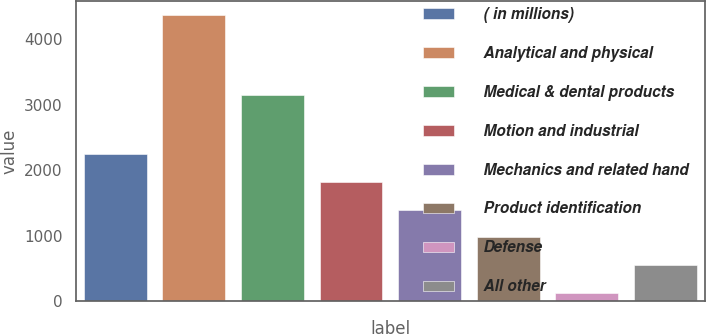Convert chart. <chart><loc_0><loc_0><loc_500><loc_500><bar_chart><fcel>( in millions)<fcel>Analytical and physical<fcel>Medical & dental products<fcel>Motion and industrial<fcel>Mechanics and related hand<fcel>Product identification<fcel>Defense<fcel>All other<nl><fcel>2245.6<fcel>4364.9<fcel>3141.9<fcel>1821.74<fcel>1397.88<fcel>974.02<fcel>126.3<fcel>550.16<nl></chart> 